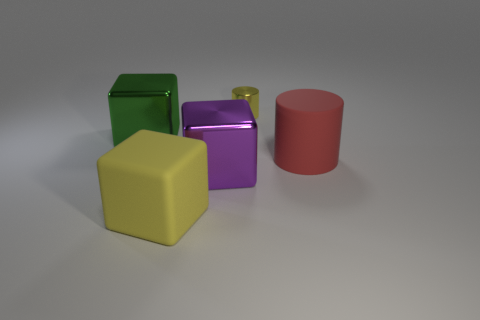Add 3 red cylinders. How many objects exist? 8 Subtract all cylinders. How many objects are left? 3 Subtract all large yellow rubber things. Subtract all purple shiny objects. How many objects are left? 3 Add 2 purple metal blocks. How many purple metal blocks are left? 3 Add 5 green metal cylinders. How many green metal cylinders exist? 5 Subtract 0 brown balls. How many objects are left? 5 